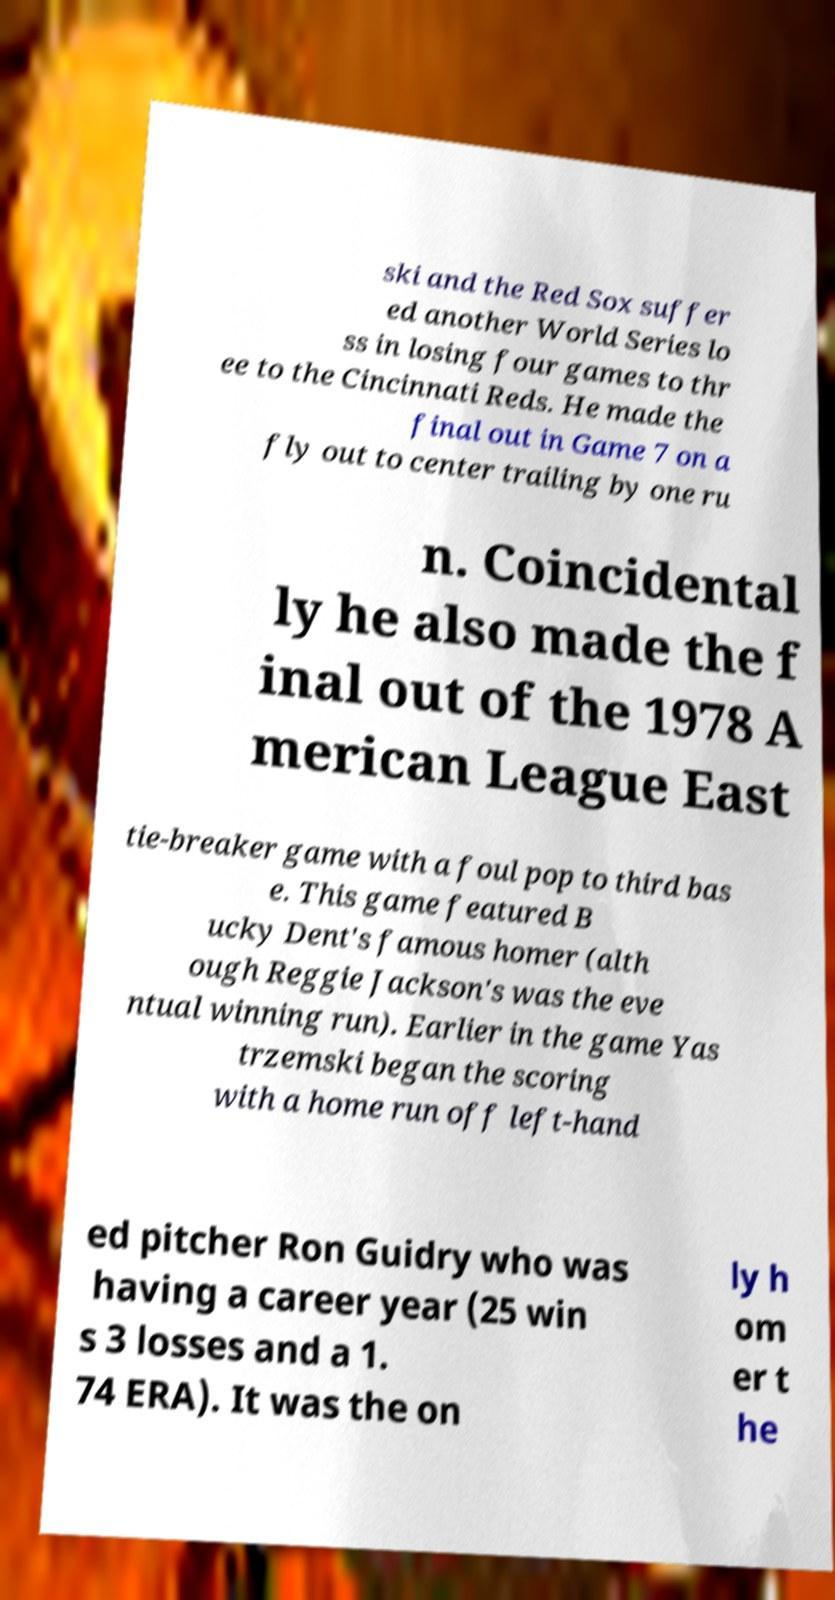Please read and relay the text visible in this image. What does it say? ski and the Red Sox suffer ed another World Series lo ss in losing four games to thr ee to the Cincinnati Reds. He made the final out in Game 7 on a fly out to center trailing by one ru n. Coincidental ly he also made the f inal out of the 1978 A merican League East tie-breaker game with a foul pop to third bas e. This game featured B ucky Dent's famous homer (alth ough Reggie Jackson's was the eve ntual winning run). Earlier in the game Yas trzemski began the scoring with a home run off left-hand ed pitcher Ron Guidry who was having a career year (25 win s 3 losses and a 1. 74 ERA). It was the on ly h om er t he 